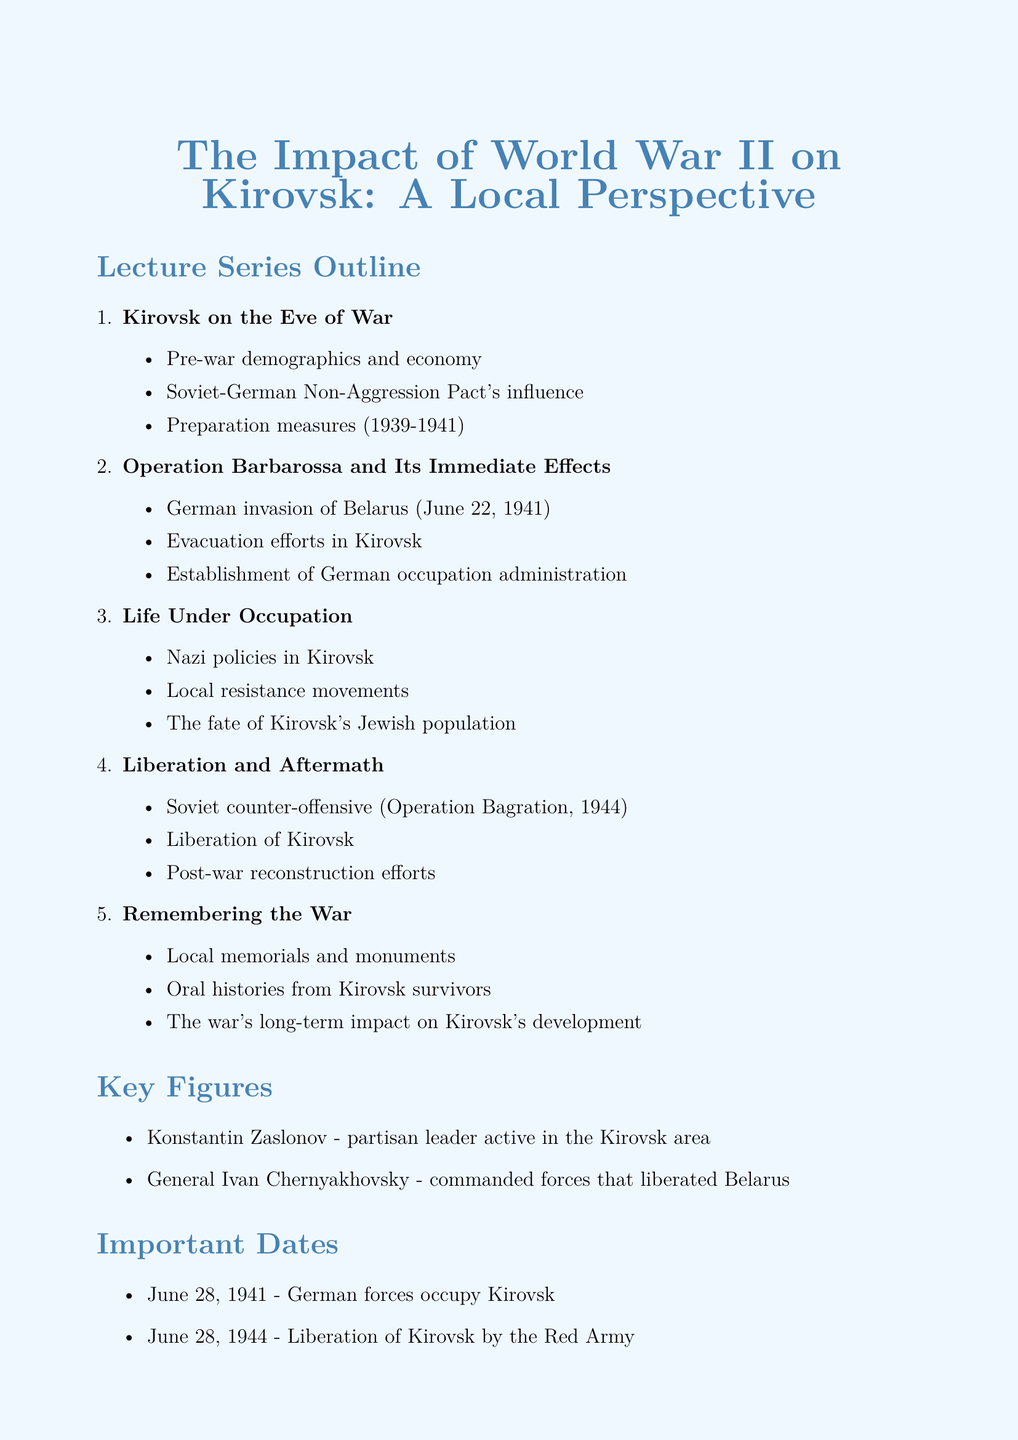What is the title of the lecture series? The title is mentioned at the beginning of the document as the focus of the entire series.
Answer: The Impact of World War II on Kirovsk: A Local Perspective What is one of the key figures associated with Kirovsk during World War II? The key figures section lists notable individuals related to Kirovsk during the war.
Answer: Konstantin Zaslonov What date did German forces occupy Kirovsk? The important dates section specifies the date of the German occupation of Kirovsk.
Answer: June 28, 1941 What was a preparation measure taken in Kirovsk between 1939 and 1941? The key points under the first lecture mention preparation measures leading up to the war.
Answer: Preparation measures in Kirovsk (1939-1941) What operation is associated with the liberation of Kirovsk? The liberation section refers to the Soviet counter-offensive that resulted in Kirovsk's liberation.
Answer: Operation Bagration Which group faced significant challenges under Nazi policies in Kirovsk? The document discusses Nazi policies affecting local communities, which highlights the impact on specific groups.
Answer: Kirovsk's Jewish population What is one suggested resource for studying Kirovsk's local history during WWII? The document lists various resources that provide further information about Kirovsk's history during and after the war.
Answer: Kirovsk Local History Museum archives What significant event occurred on June 28, 1944? The document lists important dates that outline key events related to Kirovsk during the war.
Answer: Liberation of Kirovsk by the Red Army 